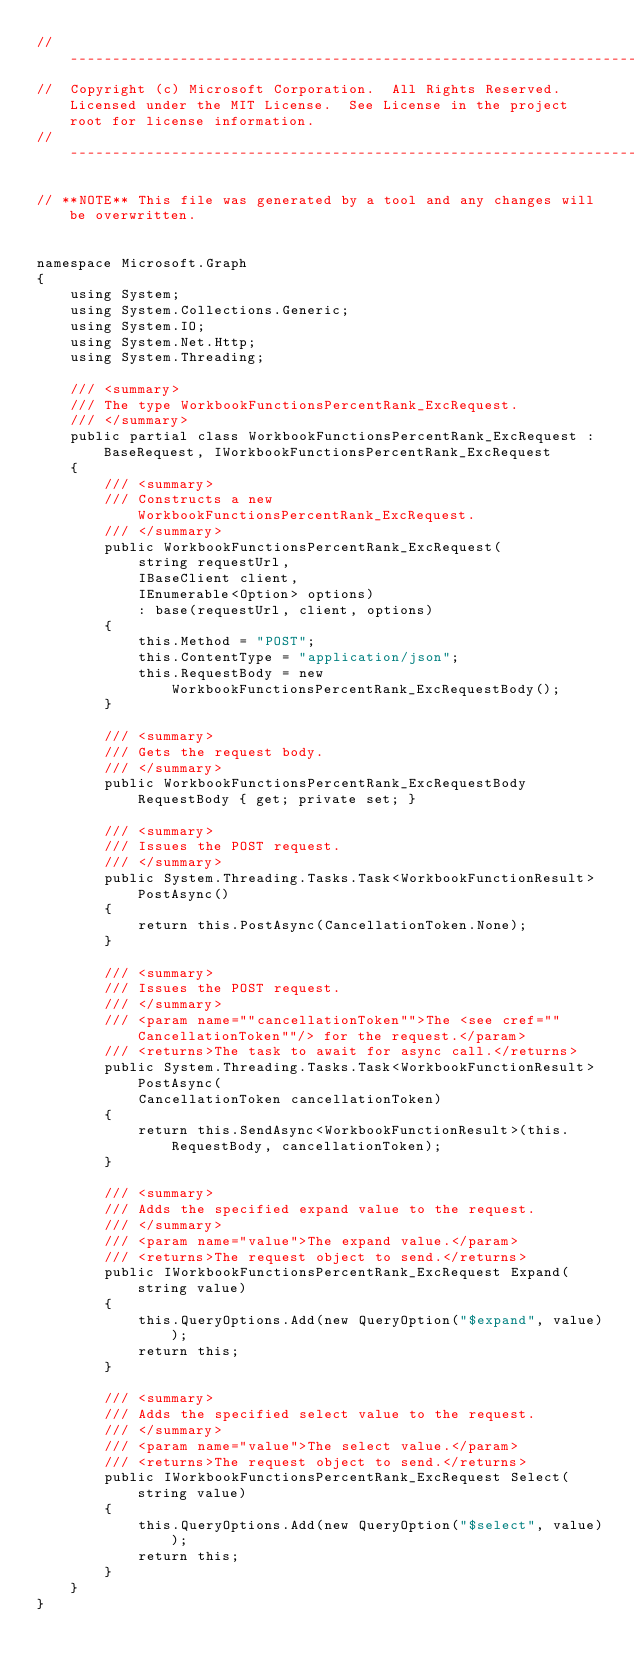<code> <loc_0><loc_0><loc_500><loc_500><_C#_>// ------------------------------------------------------------------------------
//  Copyright (c) Microsoft Corporation.  All Rights Reserved.  Licensed under the MIT License.  See License in the project root for license information.
// ------------------------------------------------------------------------------

// **NOTE** This file was generated by a tool and any changes will be overwritten.


namespace Microsoft.Graph
{
    using System;
    using System.Collections.Generic;
    using System.IO;
    using System.Net.Http;
    using System.Threading;

    /// <summary>
    /// The type WorkbookFunctionsPercentRank_ExcRequest.
    /// </summary>
    public partial class WorkbookFunctionsPercentRank_ExcRequest : BaseRequest, IWorkbookFunctionsPercentRank_ExcRequest
    {
        /// <summary>
        /// Constructs a new WorkbookFunctionsPercentRank_ExcRequest.
        /// </summary>
        public WorkbookFunctionsPercentRank_ExcRequest(
            string requestUrl,
            IBaseClient client,
            IEnumerable<Option> options)
            : base(requestUrl, client, options)
        {
            this.Method = "POST";
            this.ContentType = "application/json";
            this.RequestBody = new WorkbookFunctionsPercentRank_ExcRequestBody();
        }

        /// <summary>
        /// Gets the request body.
        /// </summary>
        public WorkbookFunctionsPercentRank_ExcRequestBody RequestBody { get; private set; }

        /// <summary>
        /// Issues the POST request.
        /// </summary>
        public System.Threading.Tasks.Task<WorkbookFunctionResult> PostAsync()
        {
            return this.PostAsync(CancellationToken.None);
        }

        /// <summary>
        /// Issues the POST request.
        /// </summary>
        /// <param name=""cancellationToken"">The <see cref=""CancellationToken""/> for the request.</param>
        /// <returns>The task to await for async call.</returns>
        public System.Threading.Tasks.Task<WorkbookFunctionResult> PostAsync(
            CancellationToken cancellationToken)
        {
            return this.SendAsync<WorkbookFunctionResult>(this.RequestBody, cancellationToken);
        }

        /// <summary>
        /// Adds the specified expand value to the request.
        /// </summary>
        /// <param name="value">The expand value.</param>
        /// <returns>The request object to send.</returns>
        public IWorkbookFunctionsPercentRank_ExcRequest Expand(string value)
        {
            this.QueryOptions.Add(new QueryOption("$expand", value));
            return this;
        }

        /// <summary>
        /// Adds the specified select value to the request.
        /// </summary>
        /// <param name="value">The select value.</param>
        /// <returns>The request object to send.</returns>
        public IWorkbookFunctionsPercentRank_ExcRequest Select(string value)
        {
            this.QueryOptions.Add(new QueryOption("$select", value));
            return this;
        }
    }
}
</code> 